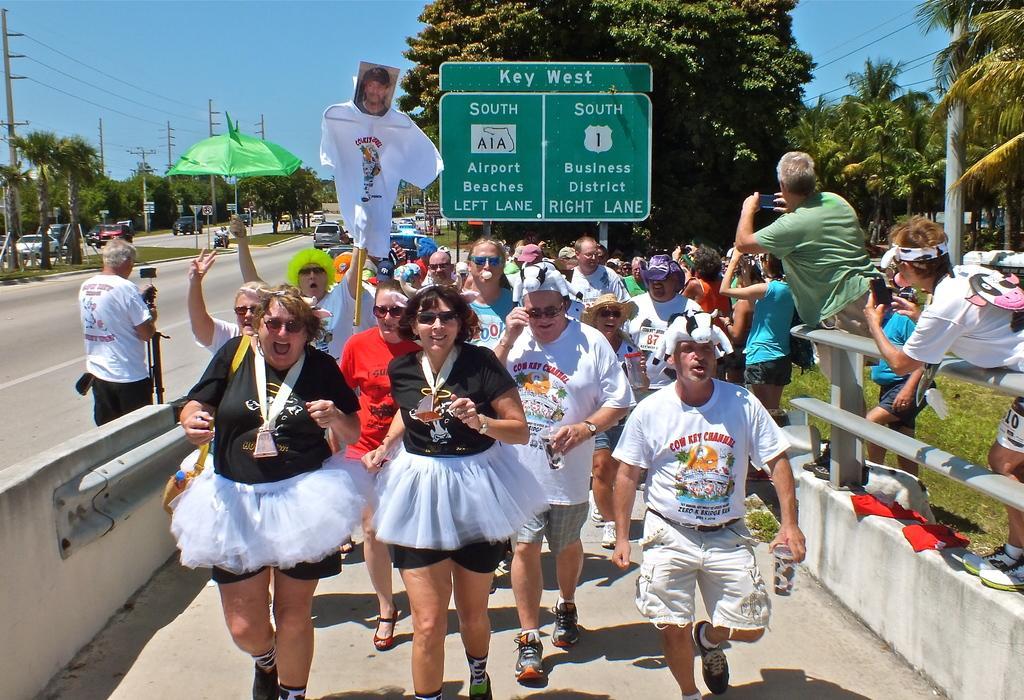Can you describe this image briefly? In this picture we can see people running on the road surrounded by trees and grass. On the left side, we can see vehicles on the other side of the road. 